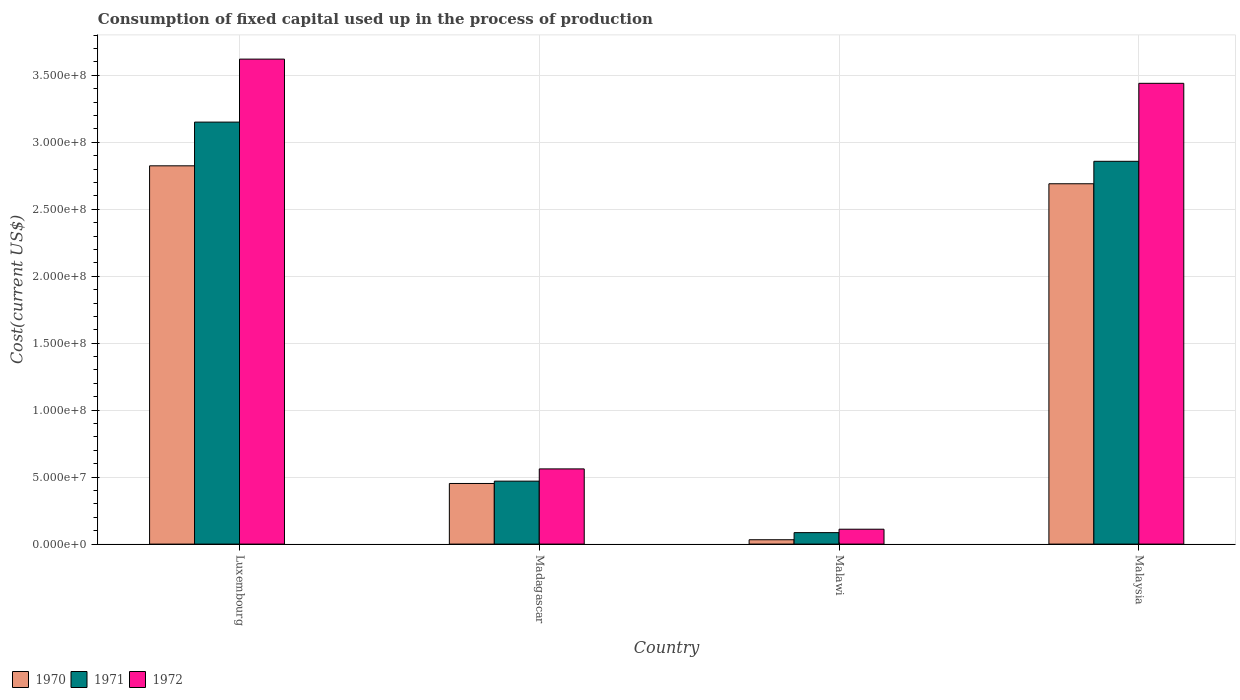How many groups of bars are there?
Offer a terse response. 4. Are the number of bars per tick equal to the number of legend labels?
Your answer should be compact. Yes. How many bars are there on the 4th tick from the right?
Offer a very short reply. 3. What is the label of the 4th group of bars from the left?
Offer a very short reply. Malaysia. What is the amount consumed in the process of production in 1972 in Malawi?
Your response must be concise. 1.11e+07. Across all countries, what is the maximum amount consumed in the process of production in 1972?
Give a very brief answer. 3.62e+08. Across all countries, what is the minimum amount consumed in the process of production in 1972?
Keep it short and to the point. 1.11e+07. In which country was the amount consumed in the process of production in 1971 maximum?
Ensure brevity in your answer.  Luxembourg. In which country was the amount consumed in the process of production in 1971 minimum?
Make the answer very short. Malawi. What is the total amount consumed in the process of production in 1970 in the graph?
Your response must be concise. 6.00e+08. What is the difference between the amount consumed in the process of production in 1971 in Luxembourg and that in Malawi?
Your answer should be very brief. 3.07e+08. What is the difference between the amount consumed in the process of production in 1970 in Madagascar and the amount consumed in the process of production in 1972 in Malaysia?
Offer a terse response. -2.99e+08. What is the average amount consumed in the process of production in 1971 per country?
Ensure brevity in your answer.  1.64e+08. What is the difference between the amount consumed in the process of production of/in 1972 and amount consumed in the process of production of/in 1970 in Luxembourg?
Offer a terse response. 7.97e+07. In how many countries, is the amount consumed in the process of production in 1970 greater than 240000000 US$?
Ensure brevity in your answer.  2. What is the ratio of the amount consumed in the process of production in 1972 in Madagascar to that in Malawi?
Your response must be concise. 5.05. Is the difference between the amount consumed in the process of production in 1972 in Luxembourg and Madagascar greater than the difference between the amount consumed in the process of production in 1970 in Luxembourg and Madagascar?
Keep it short and to the point. Yes. What is the difference between the highest and the second highest amount consumed in the process of production in 1972?
Your answer should be very brief. 3.06e+08. What is the difference between the highest and the lowest amount consumed in the process of production in 1970?
Offer a terse response. 2.79e+08. Is the sum of the amount consumed in the process of production in 1972 in Luxembourg and Madagascar greater than the maximum amount consumed in the process of production in 1970 across all countries?
Provide a short and direct response. Yes. Are all the bars in the graph horizontal?
Your answer should be very brief. No. How many countries are there in the graph?
Give a very brief answer. 4. Are the values on the major ticks of Y-axis written in scientific E-notation?
Provide a short and direct response. Yes. What is the title of the graph?
Your response must be concise. Consumption of fixed capital used up in the process of production. Does "1973" appear as one of the legend labels in the graph?
Provide a short and direct response. No. What is the label or title of the X-axis?
Offer a terse response. Country. What is the label or title of the Y-axis?
Offer a terse response. Cost(current US$). What is the Cost(current US$) in 1970 in Luxembourg?
Provide a succinct answer. 2.82e+08. What is the Cost(current US$) of 1971 in Luxembourg?
Offer a terse response. 3.15e+08. What is the Cost(current US$) of 1972 in Luxembourg?
Offer a terse response. 3.62e+08. What is the Cost(current US$) of 1970 in Madagascar?
Make the answer very short. 4.53e+07. What is the Cost(current US$) in 1971 in Madagascar?
Ensure brevity in your answer.  4.70e+07. What is the Cost(current US$) in 1972 in Madagascar?
Your response must be concise. 5.61e+07. What is the Cost(current US$) of 1970 in Malawi?
Provide a short and direct response. 3.26e+06. What is the Cost(current US$) in 1971 in Malawi?
Offer a terse response. 8.56e+06. What is the Cost(current US$) in 1972 in Malawi?
Your response must be concise. 1.11e+07. What is the Cost(current US$) of 1970 in Malaysia?
Your response must be concise. 2.69e+08. What is the Cost(current US$) of 1971 in Malaysia?
Provide a succinct answer. 2.86e+08. What is the Cost(current US$) in 1972 in Malaysia?
Offer a very short reply. 3.44e+08. Across all countries, what is the maximum Cost(current US$) in 1970?
Provide a short and direct response. 2.82e+08. Across all countries, what is the maximum Cost(current US$) in 1971?
Your answer should be very brief. 3.15e+08. Across all countries, what is the maximum Cost(current US$) in 1972?
Offer a terse response. 3.62e+08. Across all countries, what is the minimum Cost(current US$) of 1970?
Make the answer very short. 3.26e+06. Across all countries, what is the minimum Cost(current US$) of 1971?
Give a very brief answer. 8.56e+06. Across all countries, what is the minimum Cost(current US$) in 1972?
Offer a terse response. 1.11e+07. What is the total Cost(current US$) of 1970 in the graph?
Your answer should be very brief. 6.00e+08. What is the total Cost(current US$) of 1971 in the graph?
Provide a succinct answer. 6.56e+08. What is the total Cost(current US$) of 1972 in the graph?
Give a very brief answer. 7.73e+08. What is the difference between the Cost(current US$) of 1970 in Luxembourg and that in Madagascar?
Offer a very short reply. 2.37e+08. What is the difference between the Cost(current US$) in 1971 in Luxembourg and that in Madagascar?
Your response must be concise. 2.68e+08. What is the difference between the Cost(current US$) in 1972 in Luxembourg and that in Madagascar?
Give a very brief answer. 3.06e+08. What is the difference between the Cost(current US$) in 1970 in Luxembourg and that in Malawi?
Provide a short and direct response. 2.79e+08. What is the difference between the Cost(current US$) of 1971 in Luxembourg and that in Malawi?
Ensure brevity in your answer.  3.07e+08. What is the difference between the Cost(current US$) of 1972 in Luxembourg and that in Malawi?
Your response must be concise. 3.51e+08. What is the difference between the Cost(current US$) in 1970 in Luxembourg and that in Malaysia?
Offer a very short reply. 1.34e+07. What is the difference between the Cost(current US$) of 1971 in Luxembourg and that in Malaysia?
Provide a succinct answer. 2.93e+07. What is the difference between the Cost(current US$) of 1972 in Luxembourg and that in Malaysia?
Make the answer very short. 1.81e+07. What is the difference between the Cost(current US$) of 1970 in Madagascar and that in Malawi?
Make the answer very short. 4.20e+07. What is the difference between the Cost(current US$) of 1971 in Madagascar and that in Malawi?
Offer a very short reply. 3.84e+07. What is the difference between the Cost(current US$) of 1972 in Madagascar and that in Malawi?
Offer a terse response. 4.50e+07. What is the difference between the Cost(current US$) in 1970 in Madagascar and that in Malaysia?
Make the answer very short. -2.24e+08. What is the difference between the Cost(current US$) in 1971 in Madagascar and that in Malaysia?
Offer a terse response. -2.39e+08. What is the difference between the Cost(current US$) in 1972 in Madagascar and that in Malaysia?
Keep it short and to the point. -2.88e+08. What is the difference between the Cost(current US$) of 1970 in Malawi and that in Malaysia?
Give a very brief answer. -2.66e+08. What is the difference between the Cost(current US$) in 1971 in Malawi and that in Malaysia?
Your response must be concise. -2.77e+08. What is the difference between the Cost(current US$) in 1972 in Malawi and that in Malaysia?
Give a very brief answer. -3.33e+08. What is the difference between the Cost(current US$) in 1970 in Luxembourg and the Cost(current US$) in 1971 in Madagascar?
Provide a short and direct response. 2.35e+08. What is the difference between the Cost(current US$) of 1970 in Luxembourg and the Cost(current US$) of 1972 in Madagascar?
Ensure brevity in your answer.  2.26e+08. What is the difference between the Cost(current US$) in 1971 in Luxembourg and the Cost(current US$) in 1972 in Madagascar?
Your answer should be compact. 2.59e+08. What is the difference between the Cost(current US$) of 1970 in Luxembourg and the Cost(current US$) of 1971 in Malawi?
Make the answer very short. 2.74e+08. What is the difference between the Cost(current US$) of 1970 in Luxembourg and the Cost(current US$) of 1972 in Malawi?
Provide a succinct answer. 2.71e+08. What is the difference between the Cost(current US$) in 1971 in Luxembourg and the Cost(current US$) in 1972 in Malawi?
Make the answer very short. 3.04e+08. What is the difference between the Cost(current US$) of 1970 in Luxembourg and the Cost(current US$) of 1971 in Malaysia?
Your answer should be compact. -3.37e+06. What is the difference between the Cost(current US$) of 1970 in Luxembourg and the Cost(current US$) of 1972 in Malaysia?
Provide a short and direct response. -6.16e+07. What is the difference between the Cost(current US$) of 1971 in Luxembourg and the Cost(current US$) of 1972 in Malaysia?
Keep it short and to the point. -2.90e+07. What is the difference between the Cost(current US$) of 1970 in Madagascar and the Cost(current US$) of 1971 in Malawi?
Your response must be concise. 3.67e+07. What is the difference between the Cost(current US$) of 1970 in Madagascar and the Cost(current US$) of 1972 in Malawi?
Your response must be concise. 3.41e+07. What is the difference between the Cost(current US$) of 1971 in Madagascar and the Cost(current US$) of 1972 in Malawi?
Offer a very short reply. 3.59e+07. What is the difference between the Cost(current US$) in 1970 in Madagascar and the Cost(current US$) in 1971 in Malaysia?
Keep it short and to the point. -2.41e+08. What is the difference between the Cost(current US$) of 1970 in Madagascar and the Cost(current US$) of 1972 in Malaysia?
Provide a succinct answer. -2.99e+08. What is the difference between the Cost(current US$) in 1971 in Madagascar and the Cost(current US$) in 1972 in Malaysia?
Offer a terse response. -2.97e+08. What is the difference between the Cost(current US$) in 1970 in Malawi and the Cost(current US$) in 1971 in Malaysia?
Provide a short and direct response. -2.83e+08. What is the difference between the Cost(current US$) in 1970 in Malawi and the Cost(current US$) in 1972 in Malaysia?
Your answer should be compact. -3.41e+08. What is the difference between the Cost(current US$) in 1971 in Malawi and the Cost(current US$) in 1972 in Malaysia?
Your answer should be very brief. -3.35e+08. What is the average Cost(current US$) of 1970 per country?
Ensure brevity in your answer.  1.50e+08. What is the average Cost(current US$) in 1971 per country?
Your answer should be very brief. 1.64e+08. What is the average Cost(current US$) of 1972 per country?
Your answer should be very brief. 1.93e+08. What is the difference between the Cost(current US$) of 1970 and Cost(current US$) of 1971 in Luxembourg?
Provide a succinct answer. -3.26e+07. What is the difference between the Cost(current US$) of 1970 and Cost(current US$) of 1972 in Luxembourg?
Your answer should be very brief. -7.97e+07. What is the difference between the Cost(current US$) in 1971 and Cost(current US$) in 1972 in Luxembourg?
Give a very brief answer. -4.70e+07. What is the difference between the Cost(current US$) in 1970 and Cost(current US$) in 1971 in Madagascar?
Your answer should be very brief. -1.74e+06. What is the difference between the Cost(current US$) in 1970 and Cost(current US$) in 1972 in Madagascar?
Offer a terse response. -1.09e+07. What is the difference between the Cost(current US$) in 1971 and Cost(current US$) in 1972 in Madagascar?
Give a very brief answer. -9.14e+06. What is the difference between the Cost(current US$) in 1970 and Cost(current US$) in 1971 in Malawi?
Make the answer very short. -5.30e+06. What is the difference between the Cost(current US$) in 1970 and Cost(current US$) in 1972 in Malawi?
Offer a terse response. -7.86e+06. What is the difference between the Cost(current US$) of 1971 and Cost(current US$) of 1972 in Malawi?
Ensure brevity in your answer.  -2.56e+06. What is the difference between the Cost(current US$) in 1970 and Cost(current US$) in 1971 in Malaysia?
Offer a terse response. -1.68e+07. What is the difference between the Cost(current US$) of 1970 and Cost(current US$) of 1972 in Malaysia?
Keep it short and to the point. -7.50e+07. What is the difference between the Cost(current US$) in 1971 and Cost(current US$) in 1972 in Malaysia?
Offer a very short reply. -5.82e+07. What is the ratio of the Cost(current US$) of 1970 in Luxembourg to that in Madagascar?
Your answer should be very brief. 6.24. What is the ratio of the Cost(current US$) in 1971 in Luxembourg to that in Madagascar?
Offer a very short reply. 6.7. What is the ratio of the Cost(current US$) in 1972 in Luxembourg to that in Madagascar?
Provide a short and direct response. 6.45. What is the ratio of the Cost(current US$) in 1970 in Luxembourg to that in Malawi?
Your answer should be compact. 86.61. What is the ratio of the Cost(current US$) in 1971 in Luxembourg to that in Malawi?
Your answer should be very brief. 36.8. What is the ratio of the Cost(current US$) of 1972 in Luxembourg to that in Malawi?
Offer a very short reply. 32.56. What is the ratio of the Cost(current US$) in 1970 in Luxembourg to that in Malaysia?
Offer a terse response. 1.05. What is the ratio of the Cost(current US$) in 1971 in Luxembourg to that in Malaysia?
Offer a very short reply. 1.1. What is the ratio of the Cost(current US$) in 1972 in Luxembourg to that in Malaysia?
Ensure brevity in your answer.  1.05. What is the ratio of the Cost(current US$) in 1970 in Madagascar to that in Malawi?
Offer a very short reply. 13.88. What is the ratio of the Cost(current US$) of 1971 in Madagascar to that in Malawi?
Offer a terse response. 5.49. What is the ratio of the Cost(current US$) of 1972 in Madagascar to that in Malawi?
Offer a very short reply. 5.05. What is the ratio of the Cost(current US$) of 1970 in Madagascar to that in Malaysia?
Offer a terse response. 0.17. What is the ratio of the Cost(current US$) in 1971 in Madagascar to that in Malaysia?
Provide a succinct answer. 0.16. What is the ratio of the Cost(current US$) of 1972 in Madagascar to that in Malaysia?
Your response must be concise. 0.16. What is the ratio of the Cost(current US$) of 1970 in Malawi to that in Malaysia?
Ensure brevity in your answer.  0.01. What is the ratio of the Cost(current US$) in 1971 in Malawi to that in Malaysia?
Ensure brevity in your answer.  0.03. What is the ratio of the Cost(current US$) of 1972 in Malawi to that in Malaysia?
Your answer should be compact. 0.03. What is the difference between the highest and the second highest Cost(current US$) of 1970?
Make the answer very short. 1.34e+07. What is the difference between the highest and the second highest Cost(current US$) in 1971?
Provide a succinct answer. 2.93e+07. What is the difference between the highest and the second highest Cost(current US$) in 1972?
Give a very brief answer. 1.81e+07. What is the difference between the highest and the lowest Cost(current US$) of 1970?
Give a very brief answer. 2.79e+08. What is the difference between the highest and the lowest Cost(current US$) in 1971?
Your response must be concise. 3.07e+08. What is the difference between the highest and the lowest Cost(current US$) in 1972?
Give a very brief answer. 3.51e+08. 